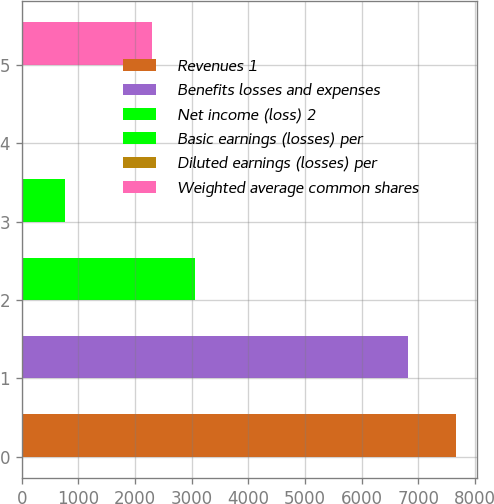Convert chart. <chart><loc_0><loc_0><loc_500><loc_500><bar_chart><fcel>Revenues 1<fcel>Benefits losses and expenses<fcel>Net income (loss) 2<fcel>Basic earnings (losses) per<fcel>Diluted earnings (losses) per<fcel>Weighted average common shares<nl><fcel>7660<fcel>6823<fcel>3065.16<fcel>767.76<fcel>1.96<fcel>2299.36<nl></chart> 